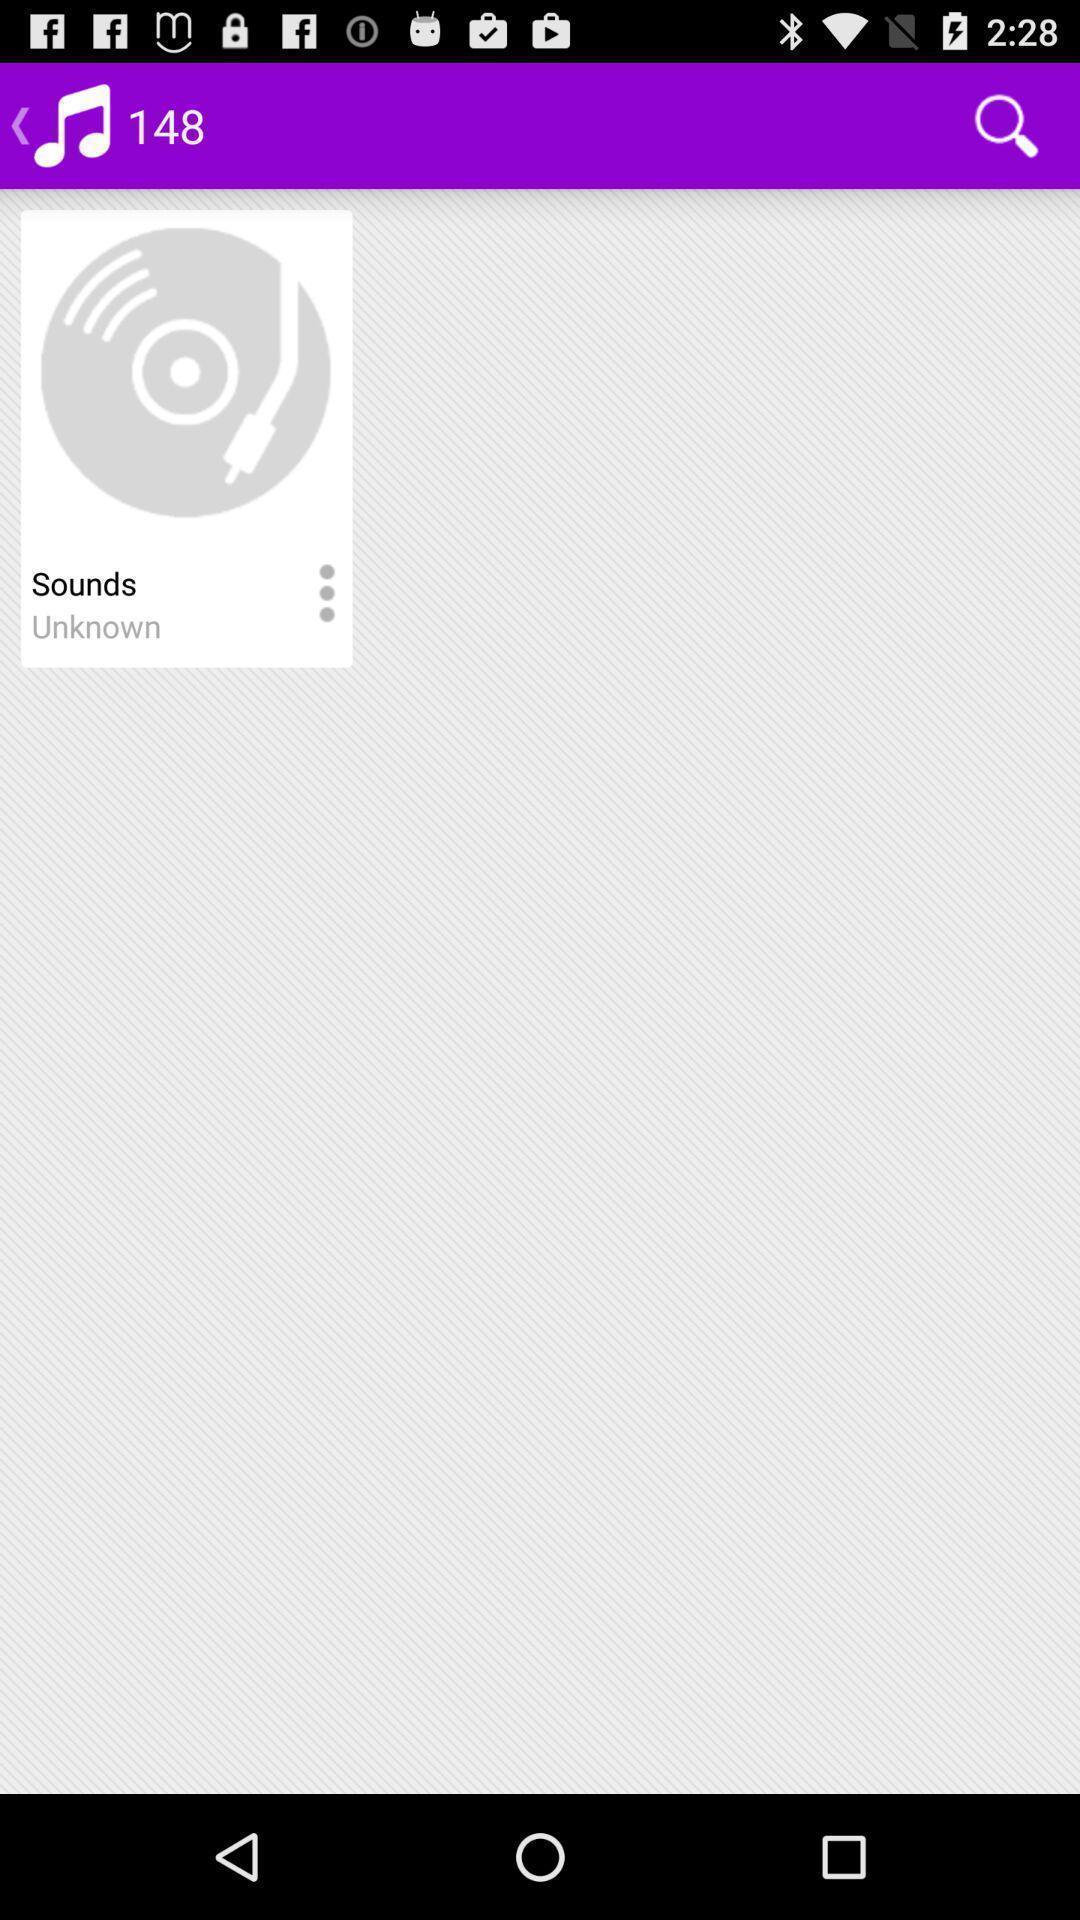What is the overall content of this screenshot? Page showing the sound track. 